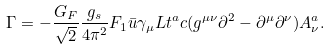Convert formula to latex. <formula><loc_0><loc_0><loc_500><loc_500>\Gamma = - \frac { G _ { F } } { \sqrt { 2 } } \frac { g _ { s } } { 4 \pi ^ { 2 } } F _ { 1 } \bar { u } \gamma _ { \mu } L t ^ { a } c ( g ^ { \mu \nu } \partial ^ { 2 } - \partial ^ { \mu } \partial ^ { \nu } ) A ^ { a } _ { \nu } .</formula> 